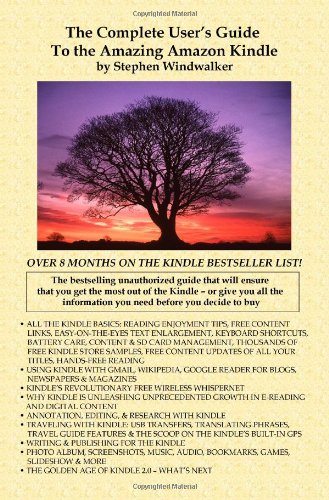Who wrote this book? This book, titled 'The Complete User's Guide to the Amazing Amazon Kindle (First Generation)', was authored by Stephen Windwalker. 